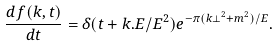Convert formula to latex. <formula><loc_0><loc_0><loc_500><loc_500>\frac { d f ( { k } , t ) } { d t } = \delta ( t + { k } . { E } / { E } ^ { 2 } ) e ^ { - \pi ( k \perp ^ { 2 } + m ^ { 2 } ) / E } .</formula> 